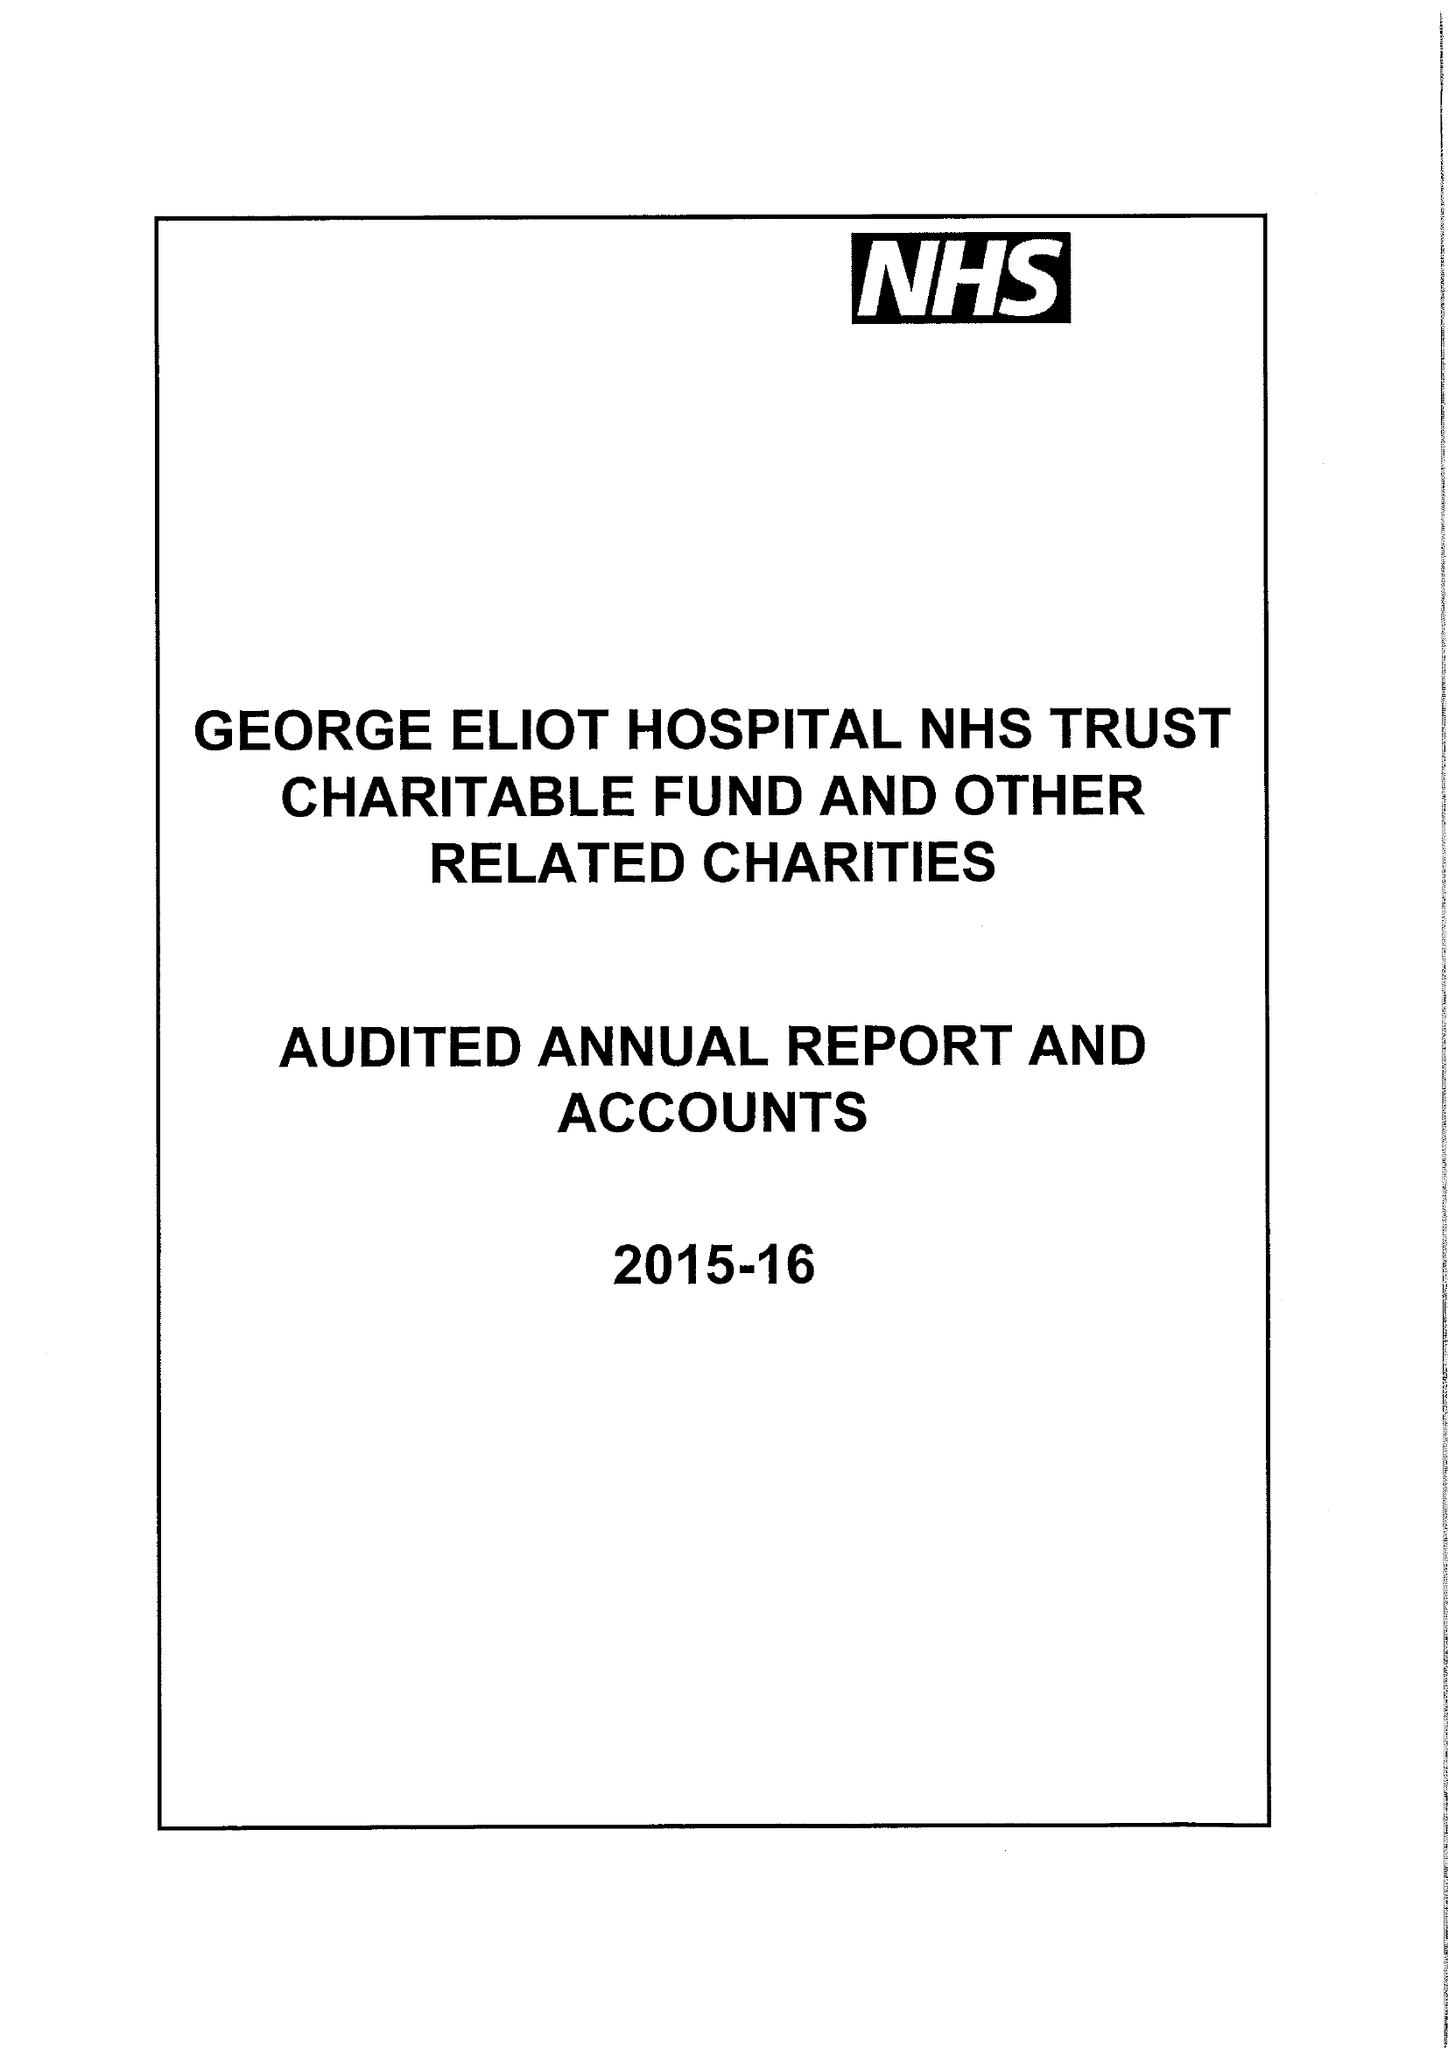What is the value for the spending_annually_in_british_pounds?
Answer the question using a single word or phrase. 190000.00 